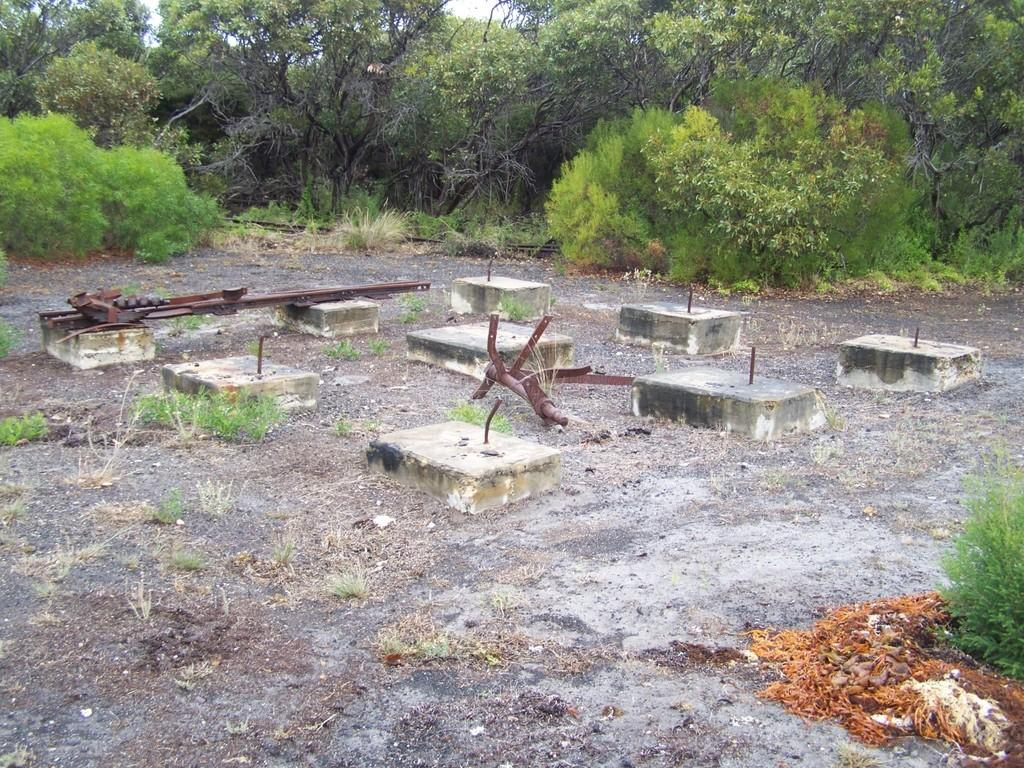What type of vegetation can be seen in the image? There are trees in the image. What type of architectural feature is present in the image? There are pillar basements in the image. What is on the ground in the image? There are plants on the ground in the image. How many cows are grazing in the image? There are no cows present in the image. What shape is the ring that is visible in the image? There is no ring present in the image. 